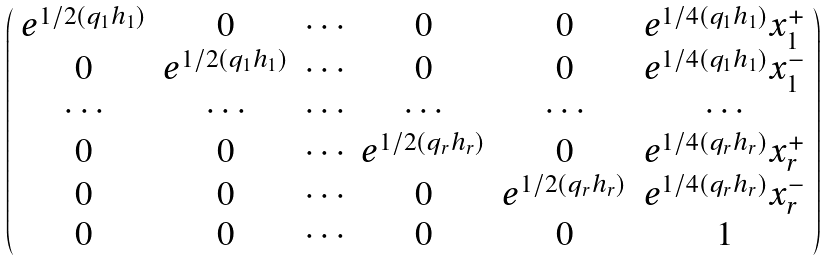Convert formula to latex. <formula><loc_0><loc_0><loc_500><loc_500>\left ( \begin{array} { c c c c c c } { { e ^ { 1 / 2 ( q _ { 1 } h _ { 1 } ) } } } & { 0 } & { \cdots } & { 0 } & { 0 } & { { e ^ { 1 / 4 ( q _ { 1 } h _ { 1 } ) } x _ { 1 } ^ { + } } } \\ { 0 } & { { e ^ { 1 / 2 ( q _ { 1 } h _ { 1 } ) } } } & { \cdots } & { 0 } & { 0 } & { { e ^ { 1 / 4 ( q _ { 1 } h _ { 1 } ) } x _ { 1 } ^ { - } } } \\ { \cdots } & { \cdots } & { \cdots } & { \cdots } & { \cdots } & { \cdots } \\ { 0 } & { 0 } & { \cdots } & { { e ^ { 1 / 2 ( q _ { r } h _ { r } ) } } } & { 0 } & { { e ^ { 1 / 4 ( q _ { r } h _ { r } ) } x _ { r } ^ { + } } } \\ { 0 } & { 0 } & { \cdots } & { 0 } & { { e ^ { 1 / 2 ( q _ { r } h _ { r } ) } } } & { { e ^ { 1 / 4 ( q _ { r } h _ { r } ) } x _ { r } ^ { - } } } \\ { 0 } & { 0 } & { \cdots } & { 0 } & { 0 } & { 1 } \end{array} \right )</formula> 